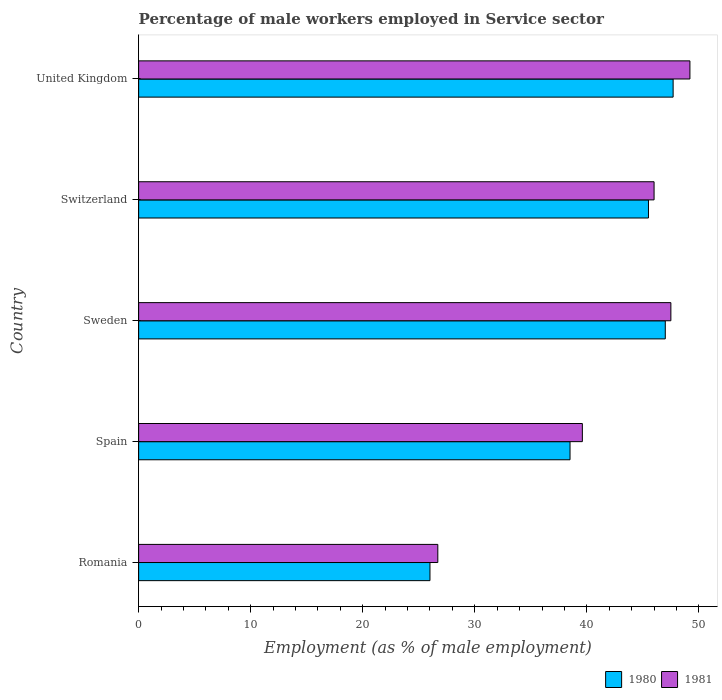In how many cases, is the number of bars for a given country not equal to the number of legend labels?
Give a very brief answer. 0. What is the percentage of male workers employed in Service sector in 1981 in Sweden?
Keep it short and to the point. 47.5. Across all countries, what is the maximum percentage of male workers employed in Service sector in 1981?
Give a very brief answer. 49.2. Across all countries, what is the minimum percentage of male workers employed in Service sector in 1981?
Offer a very short reply. 26.7. In which country was the percentage of male workers employed in Service sector in 1981 minimum?
Provide a short and direct response. Romania. What is the total percentage of male workers employed in Service sector in 1980 in the graph?
Offer a very short reply. 204.7. What is the difference between the percentage of male workers employed in Service sector in 1980 in Romania and that in United Kingdom?
Offer a terse response. -21.7. What is the difference between the percentage of male workers employed in Service sector in 1980 in Spain and the percentage of male workers employed in Service sector in 1981 in United Kingdom?
Ensure brevity in your answer.  -10.7. What is the average percentage of male workers employed in Service sector in 1981 per country?
Your response must be concise. 41.8. What is the difference between the percentage of male workers employed in Service sector in 1980 and percentage of male workers employed in Service sector in 1981 in Romania?
Your answer should be compact. -0.7. What is the ratio of the percentage of male workers employed in Service sector in 1980 in Romania to that in Spain?
Provide a succinct answer. 0.68. Is the difference between the percentage of male workers employed in Service sector in 1980 in Romania and Sweden greater than the difference between the percentage of male workers employed in Service sector in 1981 in Romania and Sweden?
Offer a terse response. No. What is the difference between the highest and the second highest percentage of male workers employed in Service sector in 1981?
Keep it short and to the point. 1.7. What is the difference between the highest and the lowest percentage of male workers employed in Service sector in 1980?
Keep it short and to the point. 21.7. In how many countries, is the percentage of male workers employed in Service sector in 1980 greater than the average percentage of male workers employed in Service sector in 1980 taken over all countries?
Offer a terse response. 3. Is the sum of the percentage of male workers employed in Service sector in 1981 in Romania and Switzerland greater than the maximum percentage of male workers employed in Service sector in 1980 across all countries?
Make the answer very short. Yes. What does the 1st bar from the bottom in Romania represents?
Make the answer very short. 1980. How many bars are there?
Give a very brief answer. 10. Are all the bars in the graph horizontal?
Make the answer very short. Yes. What is the difference between two consecutive major ticks on the X-axis?
Your answer should be compact. 10. Are the values on the major ticks of X-axis written in scientific E-notation?
Give a very brief answer. No. Does the graph contain any zero values?
Provide a short and direct response. No. Does the graph contain grids?
Your answer should be very brief. No. How are the legend labels stacked?
Keep it short and to the point. Horizontal. What is the title of the graph?
Provide a short and direct response. Percentage of male workers employed in Service sector. What is the label or title of the X-axis?
Your response must be concise. Employment (as % of male employment). What is the Employment (as % of male employment) of 1981 in Romania?
Provide a succinct answer. 26.7. What is the Employment (as % of male employment) of 1980 in Spain?
Make the answer very short. 38.5. What is the Employment (as % of male employment) of 1981 in Spain?
Give a very brief answer. 39.6. What is the Employment (as % of male employment) of 1981 in Sweden?
Your answer should be very brief. 47.5. What is the Employment (as % of male employment) in 1980 in Switzerland?
Give a very brief answer. 45.5. What is the Employment (as % of male employment) of 1980 in United Kingdom?
Give a very brief answer. 47.7. What is the Employment (as % of male employment) of 1981 in United Kingdom?
Provide a short and direct response. 49.2. Across all countries, what is the maximum Employment (as % of male employment) in 1980?
Your answer should be very brief. 47.7. Across all countries, what is the maximum Employment (as % of male employment) in 1981?
Provide a short and direct response. 49.2. Across all countries, what is the minimum Employment (as % of male employment) of 1981?
Offer a terse response. 26.7. What is the total Employment (as % of male employment) in 1980 in the graph?
Make the answer very short. 204.7. What is the total Employment (as % of male employment) in 1981 in the graph?
Your response must be concise. 209. What is the difference between the Employment (as % of male employment) in 1981 in Romania and that in Spain?
Your answer should be very brief. -12.9. What is the difference between the Employment (as % of male employment) in 1981 in Romania and that in Sweden?
Offer a terse response. -20.8. What is the difference between the Employment (as % of male employment) in 1980 in Romania and that in Switzerland?
Ensure brevity in your answer.  -19.5. What is the difference between the Employment (as % of male employment) of 1981 in Romania and that in Switzerland?
Offer a terse response. -19.3. What is the difference between the Employment (as % of male employment) in 1980 in Romania and that in United Kingdom?
Offer a very short reply. -21.7. What is the difference between the Employment (as % of male employment) in 1981 in Romania and that in United Kingdom?
Your response must be concise. -22.5. What is the difference between the Employment (as % of male employment) in 1981 in Spain and that in Sweden?
Your response must be concise. -7.9. What is the difference between the Employment (as % of male employment) in 1980 in Spain and that in Switzerland?
Provide a short and direct response. -7. What is the difference between the Employment (as % of male employment) in 1981 in Spain and that in Switzerland?
Ensure brevity in your answer.  -6.4. What is the difference between the Employment (as % of male employment) in 1980 in Spain and that in United Kingdom?
Provide a short and direct response. -9.2. What is the difference between the Employment (as % of male employment) in 1981 in Spain and that in United Kingdom?
Your answer should be very brief. -9.6. What is the difference between the Employment (as % of male employment) of 1980 in Sweden and that in Switzerland?
Offer a terse response. 1.5. What is the difference between the Employment (as % of male employment) of 1980 in Sweden and that in United Kingdom?
Provide a short and direct response. -0.7. What is the difference between the Employment (as % of male employment) in 1980 in Romania and the Employment (as % of male employment) in 1981 in Spain?
Offer a very short reply. -13.6. What is the difference between the Employment (as % of male employment) in 1980 in Romania and the Employment (as % of male employment) in 1981 in Sweden?
Make the answer very short. -21.5. What is the difference between the Employment (as % of male employment) in 1980 in Romania and the Employment (as % of male employment) in 1981 in Switzerland?
Your answer should be very brief. -20. What is the difference between the Employment (as % of male employment) of 1980 in Romania and the Employment (as % of male employment) of 1981 in United Kingdom?
Your answer should be compact. -23.2. What is the difference between the Employment (as % of male employment) in 1980 in Spain and the Employment (as % of male employment) in 1981 in Sweden?
Ensure brevity in your answer.  -9. What is the difference between the Employment (as % of male employment) in 1980 in Spain and the Employment (as % of male employment) in 1981 in Switzerland?
Provide a short and direct response. -7.5. What is the difference between the Employment (as % of male employment) in 1980 in Sweden and the Employment (as % of male employment) in 1981 in Switzerland?
Provide a short and direct response. 1. What is the average Employment (as % of male employment) of 1980 per country?
Your response must be concise. 40.94. What is the average Employment (as % of male employment) in 1981 per country?
Make the answer very short. 41.8. What is the difference between the Employment (as % of male employment) in 1980 and Employment (as % of male employment) in 1981 in Sweden?
Your response must be concise. -0.5. What is the difference between the Employment (as % of male employment) of 1980 and Employment (as % of male employment) of 1981 in Switzerland?
Give a very brief answer. -0.5. What is the difference between the Employment (as % of male employment) in 1980 and Employment (as % of male employment) in 1981 in United Kingdom?
Give a very brief answer. -1.5. What is the ratio of the Employment (as % of male employment) of 1980 in Romania to that in Spain?
Offer a terse response. 0.68. What is the ratio of the Employment (as % of male employment) of 1981 in Romania to that in Spain?
Keep it short and to the point. 0.67. What is the ratio of the Employment (as % of male employment) in 1980 in Romania to that in Sweden?
Provide a succinct answer. 0.55. What is the ratio of the Employment (as % of male employment) in 1981 in Romania to that in Sweden?
Offer a terse response. 0.56. What is the ratio of the Employment (as % of male employment) of 1981 in Romania to that in Switzerland?
Provide a succinct answer. 0.58. What is the ratio of the Employment (as % of male employment) of 1980 in Romania to that in United Kingdom?
Your response must be concise. 0.55. What is the ratio of the Employment (as % of male employment) in 1981 in Romania to that in United Kingdom?
Make the answer very short. 0.54. What is the ratio of the Employment (as % of male employment) of 1980 in Spain to that in Sweden?
Provide a short and direct response. 0.82. What is the ratio of the Employment (as % of male employment) of 1981 in Spain to that in Sweden?
Offer a terse response. 0.83. What is the ratio of the Employment (as % of male employment) of 1980 in Spain to that in Switzerland?
Keep it short and to the point. 0.85. What is the ratio of the Employment (as % of male employment) of 1981 in Spain to that in Switzerland?
Keep it short and to the point. 0.86. What is the ratio of the Employment (as % of male employment) in 1980 in Spain to that in United Kingdom?
Keep it short and to the point. 0.81. What is the ratio of the Employment (as % of male employment) of 1981 in Spain to that in United Kingdom?
Offer a terse response. 0.8. What is the ratio of the Employment (as % of male employment) in 1980 in Sweden to that in Switzerland?
Keep it short and to the point. 1.03. What is the ratio of the Employment (as % of male employment) of 1981 in Sweden to that in Switzerland?
Offer a very short reply. 1.03. What is the ratio of the Employment (as % of male employment) in 1981 in Sweden to that in United Kingdom?
Your answer should be compact. 0.97. What is the ratio of the Employment (as % of male employment) in 1980 in Switzerland to that in United Kingdom?
Your response must be concise. 0.95. What is the ratio of the Employment (as % of male employment) of 1981 in Switzerland to that in United Kingdom?
Offer a very short reply. 0.94. What is the difference between the highest and the second highest Employment (as % of male employment) of 1980?
Offer a very short reply. 0.7. What is the difference between the highest and the second highest Employment (as % of male employment) of 1981?
Offer a very short reply. 1.7. What is the difference between the highest and the lowest Employment (as % of male employment) in 1980?
Keep it short and to the point. 21.7. What is the difference between the highest and the lowest Employment (as % of male employment) of 1981?
Provide a succinct answer. 22.5. 